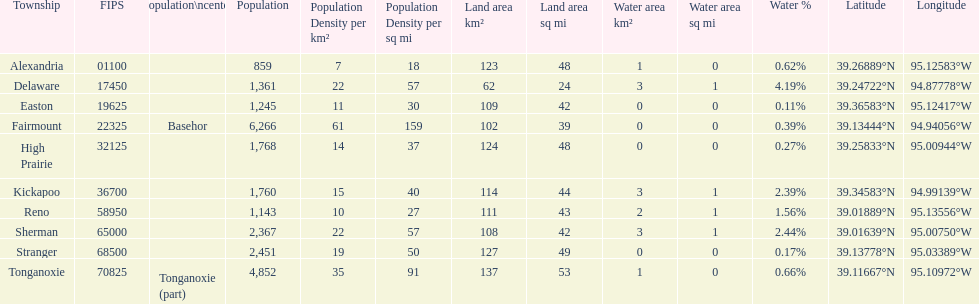Does alexandria county have a higher or lower population than delaware county? Lower. 